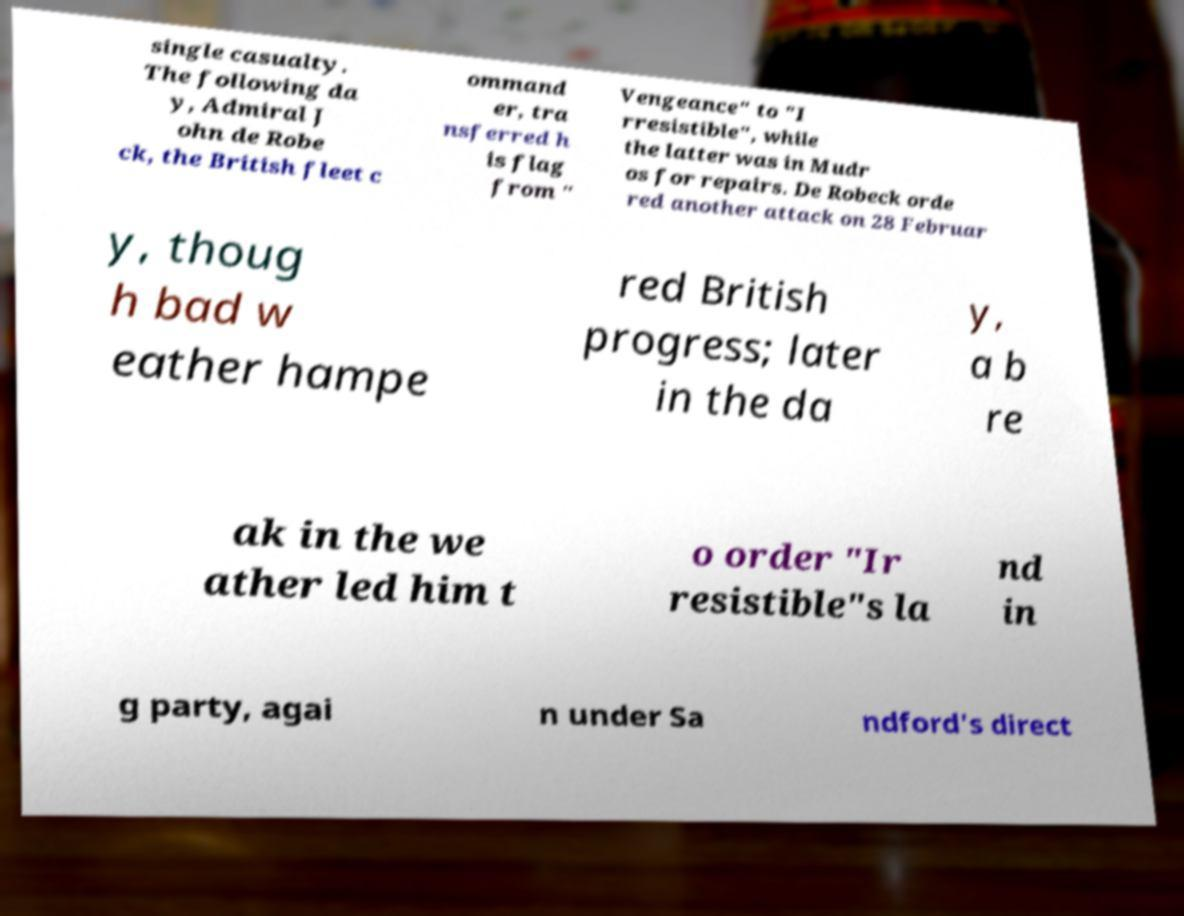Could you assist in decoding the text presented in this image and type it out clearly? single casualty. The following da y, Admiral J ohn de Robe ck, the British fleet c ommand er, tra nsferred h is flag from " Vengeance" to "I rresistible", while the latter was in Mudr os for repairs. De Robeck orde red another attack on 28 Februar y, thoug h bad w eather hampe red British progress; later in the da y, a b re ak in the we ather led him t o order "Ir resistible"s la nd in g party, agai n under Sa ndford's direct 